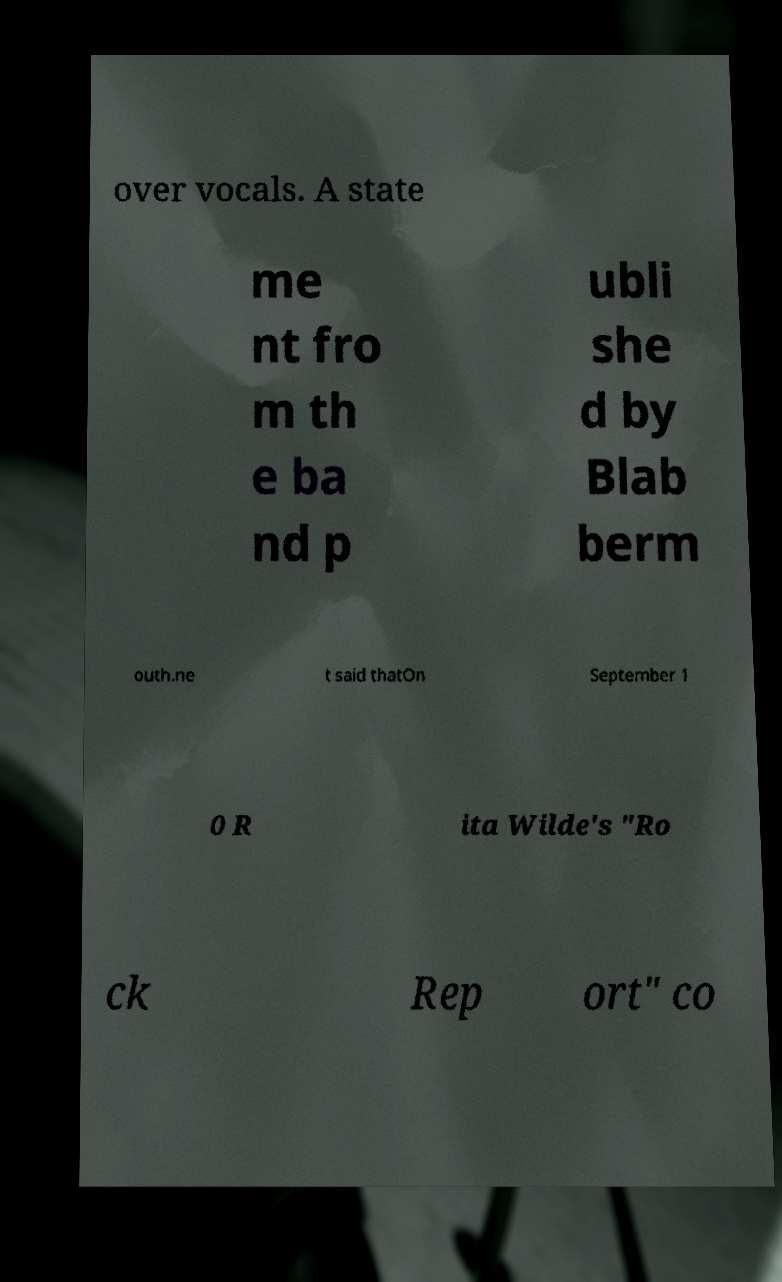I need the written content from this picture converted into text. Can you do that? over vocals. A state me nt fro m th e ba nd p ubli she d by Blab berm outh.ne t said thatOn September 1 0 R ita Wilde's "Ro ck Rep ort" co 